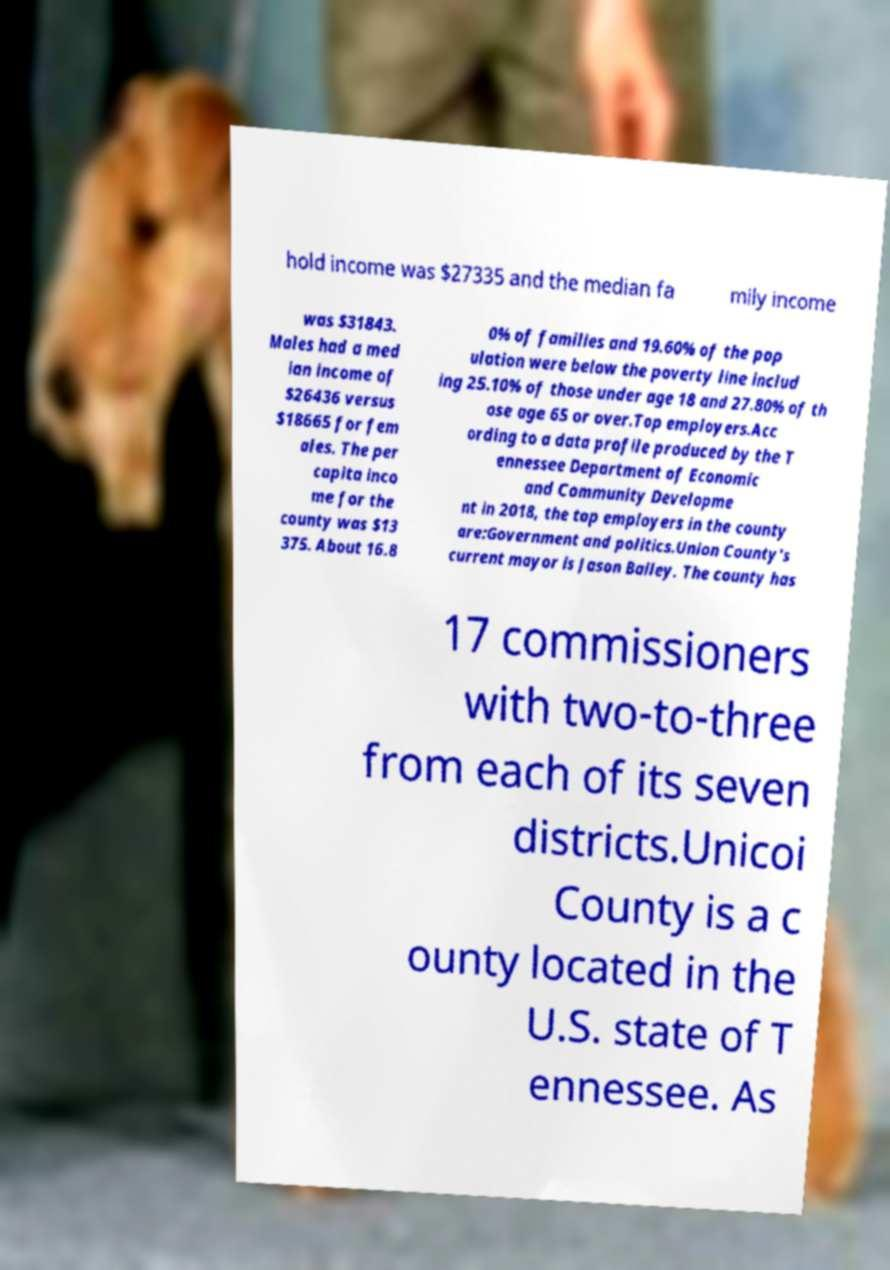I need the written content from this picture converted into text. Can you do that? hold income was $27335 and the median fa mily income was $31843. Males had a med ian income of $26436 versus $18665 for fem ales. The per capita inco me for the county was $13 375. About 16.8 0% of families and 19.60% of the pop ulation were below the poverty line includ ing 25.10% of those under age 18 and 27.80% of th ose age 65 or over.Top employers.Acc ording to a data profile produced by the T ennessee Department of Economic and Community Developme nt in 2018, the top employers in the county are:Government and politics.Union County's current mayor is Jason Bailey. The county has 17 commissioners with two-to-three from each of its seven districts.Unicoi County is a c ounty located in the U.S. state of T ennessee. As 